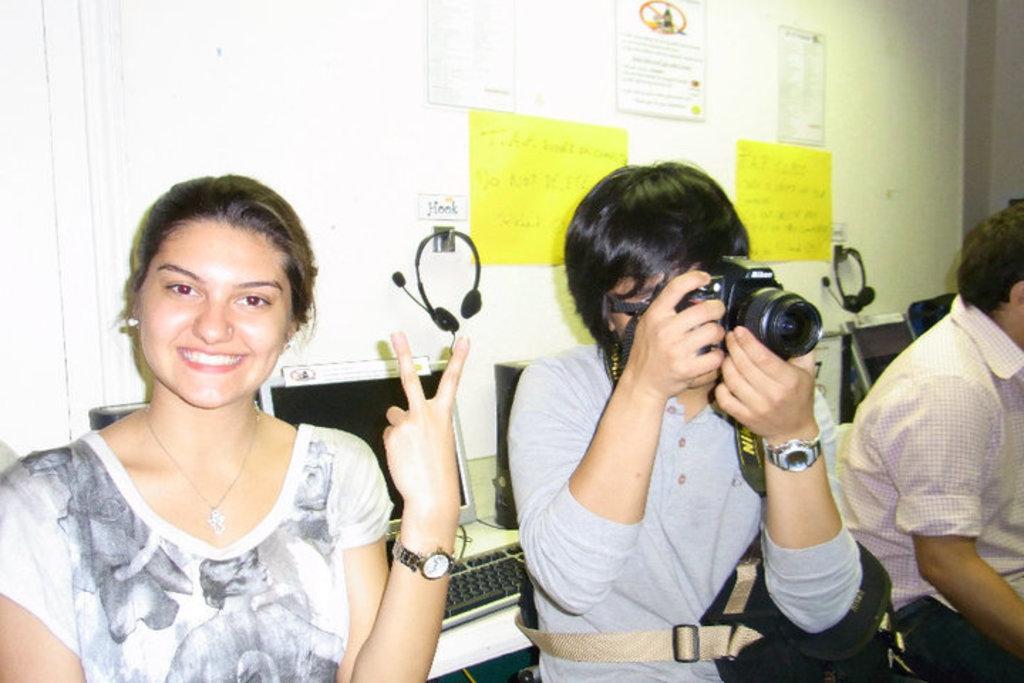Could you give a brief overview of what you see in this image? The person wearing grey shirt is holding a guitar in his hand and there are two persons sitting in the either side of him and there are computers in the background. 